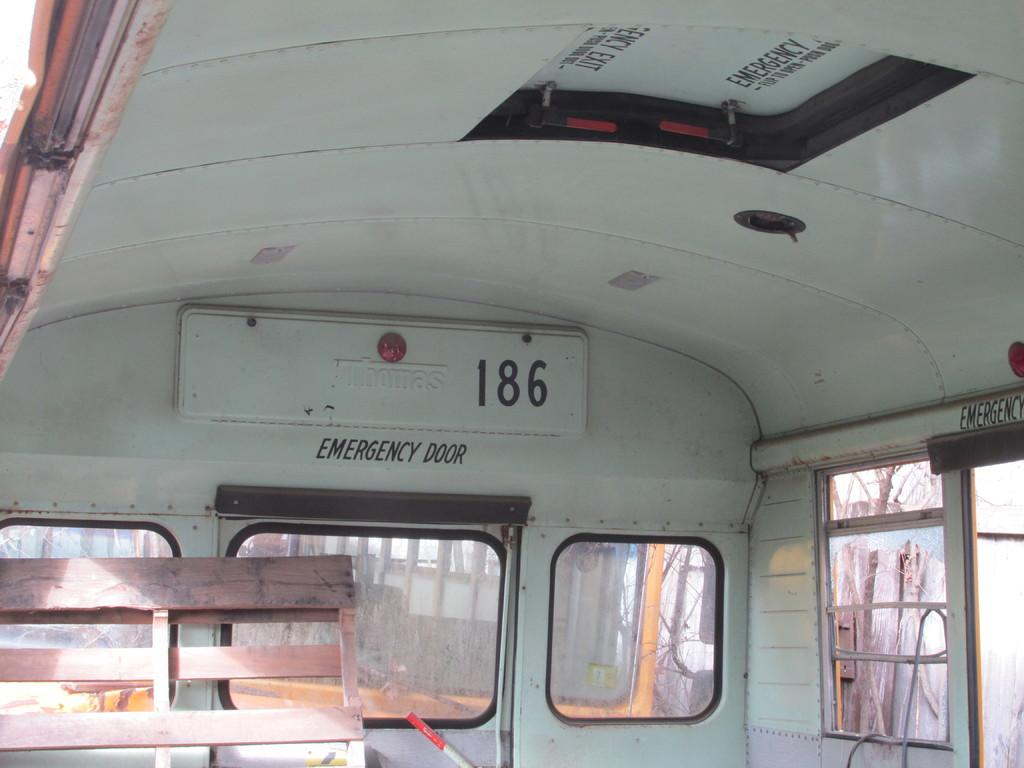Where was the image taken? The image was taken inside a vehicle. What type of structure can be seen in the image? There is a wooden structure in the image. What is used to support the wooden structure? There is a rod in the image that supports the wooden structure. What type of windows are present in the vehicle? There are glass windows in the image. What can be seen through the glass windows? Trees are visible through the glass windows. What type of rest can be seen in the image? There is no rest visible in the image; it features a wooden structure, a rod, glass windows, and trees. Does the existence of the wooden structure in the image prove the existence of a parallel universe? The presence of a wooden structure in the image does not prove the existence of a parallel universe; it is simply a structure within the context of the image. 